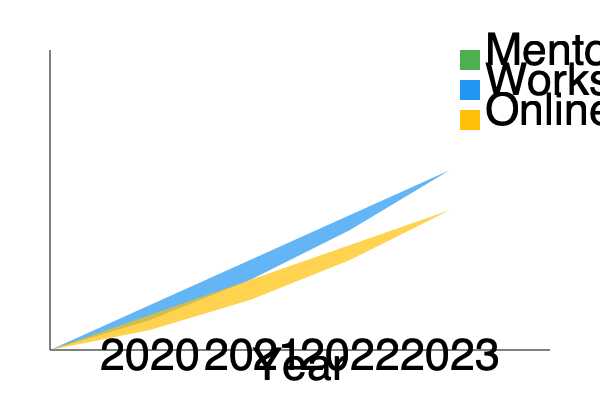Based on the stacked area chart showing adoption rates of various leadership development programs over time, which program consistently demonstrated the highest growth rate from 2020 to 2023? To determine which program had the highest growth rate, we need to analyze the slope of each area in the chart:

1. Mentoring (green):
   - 2020 to 2021: Increase from 50% to 100% (50% growth)
   - 2021 to 2022: Increase from 100% to 150% (50% growth)
   - 2022 to 2023: Increase from 150% to 200% (50% growth)
   - Consistent 50% growth each year

2. Workshops (blue):
   - 2020 to 2021: Increase from 30% to 70% (40% growth)
   - 2021 to 2022: Increase from 70% to 120% (50% growth)
   - 2022 to 2023: Increase from 120% to 180% (60% growth)
   - Increasing growth rate, but not consistent

3. Online Courses (yellow):
   - 2020 to 2021: Increase from 20% to 50% (30% growth)
   - 2021 to 2022: Increase from 50% to 90% (40% growth)
   - 2022 to 2023: Increase from 90% to 140% (50% growth)
   - Increasing growth rate, but not consistent

Mentoring shows a consistent 50% growth rate each year, while the other programs have varying growth rates. Therefore, mentoring demonstrated the highest consistent growth rate from 2020 to 2023.
Answer: Mentoring 